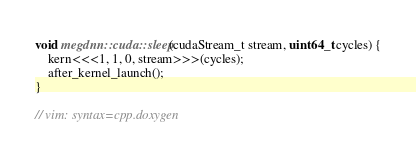Convert code to text. <code><loc_0><loc_0><loc_500><loc_500><_Cuda_>void megdnn::cuda::sleep(cudaStream_t stream, uint64_t cycles) {
    kern<<<1, 1, 0, stream>>>(cycles);
    after_kernel_launch();
}

// vim: syntax=cpp.doxygen
</code> 